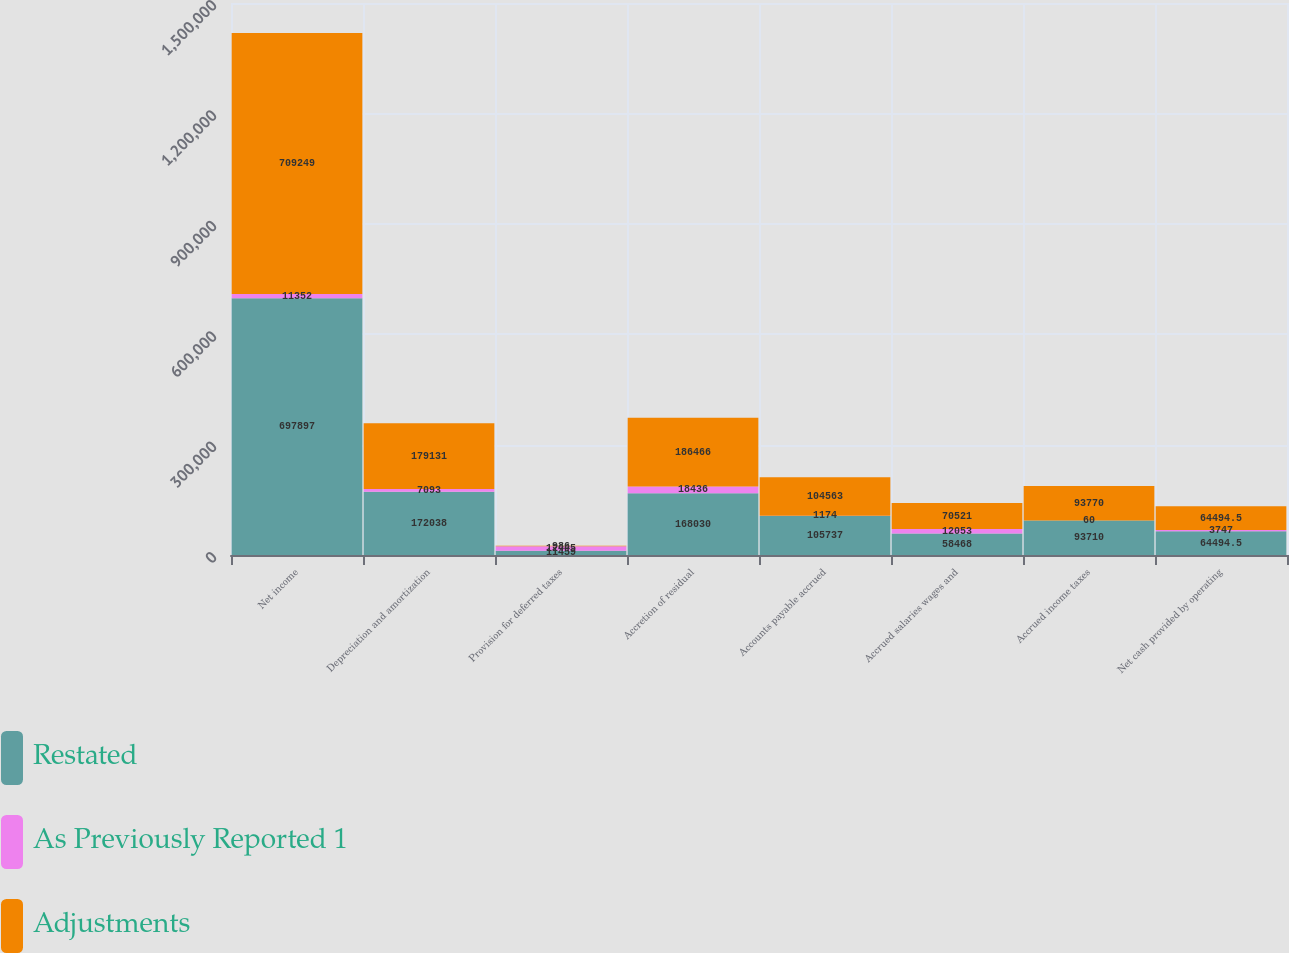Convert chart. <chart><loc_0><loc_0><loc_500><loc_500><stacked_bar_chart><ecel><fcel>Net income<fcel>Depreciation and amortization<fcel>Provision for deferred taxes<fcel>Accretion of residual<fcel>Accounts payable accrued<fcel>Accrued salaries wages and<fcel>Accrued income taxes<fcel>Net cash provided by operating<nl><fcel>Restated<fcel>697897<fcel>172038<fcel>11459<fcel>168030<fcel>105737<fcel>58468<fcel>93710<fcel>64494.5<nl><fcel>As Previously Reported 1<fcel>11352<fcel>7093<fcel>12445<fcel>18436<fcel>1174<fcel>12053<fcel>60<fcel>3747<nl><fcel>Adjustments<fcel>709249<fcel>179131<fcel>986<fcel>186466<fcel>104563<fcel>70521<fcel>93770<fcel>64494.5<nl></chart> 